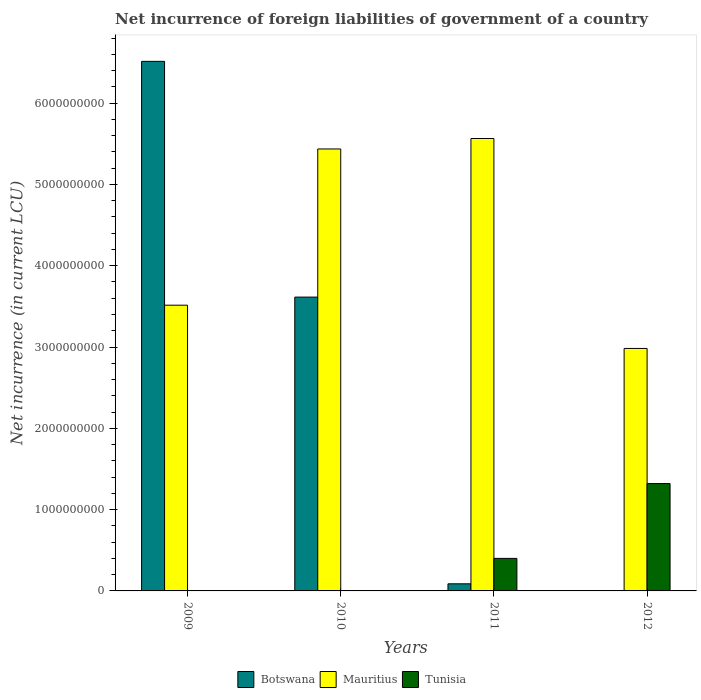How many groups of bars are there?
Offer a very short reply. 4. Are the number of bars on each tick of the X-axis equal?
Offer a terse response. No. How many bars are there on the 4th tick from the right?
Your response must be concise. 2. What is the label of the 3rd group of bars from the left?
Offer a very short reply. 2011. What is the net incurrence of foreign liabilities in Mauritius in 2010?
Offer a terse response. 5.44e+09. Across all years, what is the maximum net incurrence of foreign liabilities in Tunisia?
Give a very brief answer. 1.32e+09. Across all years, what is the minimum net incurrence of foreign liabilities in Mauritius?
Make the answer very short. 2.98e+09. In which year was the net incurrence of foreign liabilities in Mauritius maximum?
Your answer should be compact. 2011. What is the total net incurrence of foreign liabilities in Mauritius in the graph?
Ensure brevity in your answer.  1.75e+1. What is the difference between the net incurrence of foreign liabilities in Botswana in 2009 and that in 2011?
Your response must be concise. 6.43e+09. What is the difference between the net incurrence of foreign liabilities in Botswana in 2011 and the net incurrence of foreign liabilities in Tunisia in 2012?
Your answer should be very brief. -1.23e+09. What is the average net incurrence of foreign liabilities in Tunisia per year?
Give a very brief answer. 4.30e+08. In the year 2011, what is the difference between the net incurrence of foreign liabilities in Mauritius and net incurrence of foreign liabilities in Botswana?
Your answer should be very brief. 5.48e+09. What is the ratio of the net incurrence of foreign liabilities in Mauritius in 2010 to that in 2011?
Offer a terse response. 0.98. What is the difference between the highest and the second highest net incurrence of foreign liabilities in Botswana?
Your answer should be very brief. 2.90e+09. What is the difference between the highest and the lowest net incurrence of foreign liabilities in Tunisia?
Your answer should be very brief. 1.32e+09. In how many years, is the net incurrence of foreign liabilities in Mauritius greater than the average net incurrence of foreign liabilities in Mauritius taken over all years?
Your response must be concise. 2. Is it the case that in every year, the sum of the net incurrence of foreign liabilities in Botswana and net incurrence of foreign liabilities in Mauritius is greater than the net incurrence of foreign liabilities in Tunisia?
Your response must be concise. Yes. Does the graph contain any zero values?
Keep it short and to the point. Yes. Does the graph contain grids?
Your answer should be very brief. No. How many legend labels are there?
Ensure brevity in your answer.  3. What is the title of the graph?
Offer a terse response. Net incurrence of foreign liabilities of government of a country. What is the label or title of the Y-axis?
Your response must be concise. Net incurrence (in current LCU). What is the Net incurrence (in current LCU) in Botswana in 2009?
Provide a short and direct response. 6.51e+09. What is the Net incurrence (in current LCU) of Mauritius in 2009?
Keep it short and to the point. 3.51e+09. What is the Net incurrence (in current LCU) in Botswana in 2010?
Offer a terse response. 3.61e+09. What is the Net incurrence (in current LCU) of Mauritius in 2010?
Your answer should be very brief. 5.44e+09. What is the Net incurrence (in current LCU) of Botswana in 2011?
Provide a succinct answer. 8.75e+07. What is the Net incurrence (in current LCU) in Mauritius in 2011?
Your response must be concise. 5.56e+09. What is the Net incurrence (in current LCU) in Tunisia in 2011?
Your answer should be very brief. 4.00e+08. What is the Net incurrence (in current LCU) of Mauritius in 2012?
Provide a short and direct response. 2.98e+09. What is the Net incurrence (in current LCU) in Tunisia in 2012?
Provide a short and direct response. 1.32e+09. Across all years, what is the maximum Net incurrence (in current LCU) in Botswana?
Make the answer very short. 6.51e+09. Across all years, what is the maximum Net incurrence (in current LCU) of Mauritius?
Provide a succinct answer. 5.56e+09. Across all years, what is the maximum Net incurrence (in current LCU) of Tunisia?
Provide a short and direct response. 1.32e+09. Across all years, what is the minimum Net incurrence (in current LCU) in Botswana?
Your answer should be compact. 0. Across all years, what is the minimum Net incurrence (in current LCU) of Mauritius?
Ensure brevity in your answer.  2.98e+09. Across all years, what is the minimum Net incurrence (in current LCU) of Tunisia?
Ensure brevity in your answer.  0. What is the total Net incurrence (in current LCU) of Botswana in the graph?
Provide a short and direct response. 1.02e+1. What is the total Net incurrence (in current LCU) in Mauritius in the graph?
Offer a terse response. 1.75e+1. What is the total Net incurrence (in current LCU) in Tunisia in the graph?
Keep it short and to the point. 1.72e+09. What is the difference between the Net incurrence (in current LCU) in Botswana in 2009 and that in 2010?
Provide a succinct answer. 2.90e+09. What is the difference between the Net incurrence (in current LCU) in Mauritius in 2009 and that in 2010?
Provide a succinct answer. -1.92e+09. What is the difference between the Net incurrence (in current LCU) of Botswana in 2009 and that in 2011?
Make the answer very short. 6.43e+09. What is the difference between the Net incurrence (in current LCU) in Mauritius in 2009 and that in 2011?
Provide a succinct answer. -2.05e+09. What is the difference between the Net incurrence (in current LCU) in Mauritius in 2009 and that in 2012?
Your answer should be compact. 5.32e+08. What is the difference between the Net incurrence (in current LCU) in Botswana in 2010 and that in 2011?
Give a very brief answer. 3.53e+09. What is the difference between the Net incurrence (in current LCU) in Mauritius in 2010 and that in 2011?
Your answer should be very brief. -1.28e+08. What is the difference between the Net incurrence (in current LCU) in Mauritius in 2010 and that in 2012?
Ensure brevity in your answer.  2.45e+09. What is the difference between the Net incurrence (in current LCU) of Mauritius in 2011 and that in 2012?
Offer a terse response. 2.58e+09. What is the difference between the Net incurrence (in current LCU) in Tunisia in 2011 and that in 2012?
Offer a terse response. -9.20e+08. What is the difference between the Net incurrence (in current LCU) of Botswana in 2009 and the Net incurrence (in current LCU) of Mauritius in 2010?
Offer a very short reply. 1.08e+09. What is the difference between the Net incurrence (in current LCU) in Botswana in 2009 and the Net incurrence (in current LCU) in Mauritius in 2011?
Give a very brief answer. 9.49e+08. What is the difference between the Net incurrence (in current LCU) of Botswana in 2009 and the Net incurrence (in current LCU) of Tunisia in 2011?
Your answer should be very brief. 6.11e+09. What is the difference between the Net incurrence (in current LCU) in Mauritius in 2009 and the Net incurrence (in current LCU) in Tunisia in 2011?
Offer a terse response. 3.11e+09. What is the difference between the Net incurrence (in current LCU) of Botswana in 2009 and the Net incurrence (in current LCU) of Mauritius in 2012?
Give a very brief answer. 3.53e+09. What is the difference between the Net incurrence (in current LCU) of Botswana in 2009 and the Net incurrence (in current LCU) of Tunisia in 2012?
Your answer should be compact. 5.19e+09. What is the difference between the Net incurrence (in current LCU) of Mauritius in 2009 and the Net incurrence (in current LCU) of Tunisia in 2012?
Your response must be concise. 2.19e+09. What is the difference between the Net incurrence (in current LCU) of Botswana in 2010 and the Net incurrence (in current LCU) of Mauritius in 2011?
Keep it short and to the point. -1.95e+09. What is the difference between the Net incurrence (in current LCU) of Botswana in 2010 and the Net incurrence (in current LCU) of Tunisia in 2011?
Provide a succinct answer. 3.21e+09. What is the difference between the Net incurrence (in current LCU) of Mauritius in 2010 and the Net incurrence (in current LCU) of Tunisia in 2011?
Your answer should be compact. 5.04e+09. What is the difference between the Net incurrence (in current LCU) in Botswana in 2010 and the Net incurrence (in current LCU) in Mauritius in 2012?
Your response must be concise. 6.32e+08. What is the difference between the Net incurrence (in current LCU) in Botswana in 2010 and the Net incurrence (in current LCU) in Tunisia in 2012?
Keep it short and to the point. 2.29e+09. What is the difference between the Net incurrence (in current LCU) of Mauritius in 2010 and the Net incurrence (in current LCU) of Tunisia in 2012?
Offer a terse response. 4.12e+09. What is the difference between the Net incurrence (in current LCU) of Botswana in 2011 and the Net incurrence (in current LCU) of Mauritius in 2012?
Provide a succinct answer. -2.89e+09. What is the difference between the Net incurrence (in current LCU) in Botswana in 2011 and the Net incurrence (in current LCU) in Tunisia in 2012?
Offer a very short reply. -1.23e+09. What is the difference between the Net incurrence (in current LCU) of Mauritius in 2011 and the Net incurrence (in current LCU) of Tunisia in 2012?
Provide a succinct answer. 4.24e+09. What is the average Net incurrence (in current LCU) of Botswana per year?
Your response must be concise. 2.55e+09. What is the average Net incurrence (in current LCU) of Mauritius per year?
Provide a succinct answer. 4.37e+09. What is the average Net incurrence (in current LCU) of Tunisia per year?
Ensure brevity in your answer.  4.30e+08. In the year 2009, what is the difference between the Net incurrence (in current LCU) in Botswana and Net incurrence (in current LCU) in Mauritius?
Keep it short and to the point. 3.00e+09. In the year 2010, what is the difference between the Net incurrence (in current LCU) in Botswana and Net incurrence (in current LCU) in Mauritius?
Give a very brief answer. -1.82e+09. In the year 2011, what is the difference between the Net incurrence (in current LCU) in Botswana and Net incurrence (in current LCU) in Mauritius?
Ensure brevity in your answer.  -5.48e+09. In the year 2011, what is the difference between the Net incurrence (in current LCU) in Botswana and Net incurrence (in current LCU) in Tunisia?
Your answer should be very brief. -3.13e+08. In the year 2011, what is the difference between the Net incurrence (in current LCU) of Mauritius and Net incurrence (in current LCU) of Tunisia?
Give a very brief answer. 5.16e+09. In the year 2012, what is the difference between the Net incurrence (in current LCU) in Mauritius and Net incurrence (in current LCU) in Tunisia?
Provide a succinct answer. 1.66e+09. What is the ratio of the Net incurrence (in current LCU) in Botswana in 2009 to that in 2010?
Give a very brief answer. 1.8. What is the ratio of the Net incurrence (in current LCU) of Mauritius in 2009 to that in 2010?
Make the answer very short. 0.65. What is the ratio of the Net incurrence (in current LCU) in Botswana in 2009 to that in 2011?
Provide a short and direct response. 74.45. What is the ratio of the Net incurrence (in current LCU) of Mauritius in 2009 to that in 2011?
Your answer should be compact. 0.63. What is the ratio of the Net incurrence (in current LCU) of Mauritius in 2009 to that in 2012?
Your answer should be very brief. 1.18. What is the ratio of the Net incurrence (in current LCU) of Botswana in 2010 to that in 2011?
Your answer should be compact. 41.31. What is the ratio of the Net incurrence (in current LCU) of Mauritius in 2010 to that in 2011?
Your response must be concise. 0.98. What is the ratio of the Net incurrence (in current LCU) of Mauritius in 2010 to that in 2012?
Keep it short and to the point. 1.82. What is the ratio of the Net incurrence (in current LCU) in Mauritius in 2011 to that in 2012?
Offer a terse response. 1.87. What is the ratio of the Net incurrence (in current LCU) of Tunisia in 2011 to that in 2012?
Ensure brevity in your answer.  0.3. What is the difference between the highest and the second highest Net incurrence (in current LCU) of Botswana?
Give a very brief answer. 2.90e+09. What is the difference between the highest and the second highest Net incurrence (in current LCU) in Mauritius?
Your answer should be very brief. 1.28e+08. What is the difference between the highest and the lowest Net incurrence (in current LCU) in Botswana?
Give a very brief answer. 6.51e+09. What is the difference between the highest and the lowest Net incurrence (in current LCU) in Mauritius?
Keep it short and to the point. 2.58e+09. What is the difference between the highest and the lowest Net incurrence (in current LCU) in Tunisia?
Provide a succinct answer. 1.32e+09. 